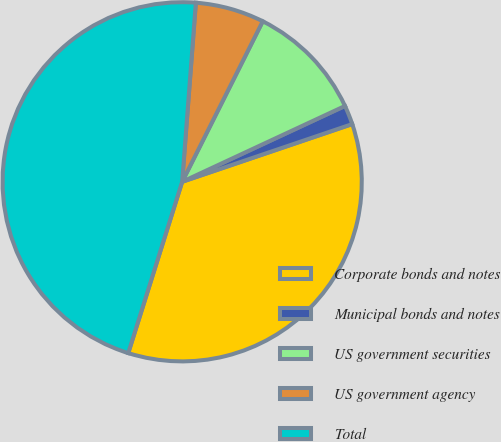<chart> <loc_0><loc_0><loc_500><loc_500><pie_chart><fcel>Corporate bonds and notes<fcel>Municipal bonds and notes<fcel>US government securities<fcel>US government agency<fcel>Total<nl><fcel>35.06%<fcel>1.73%<fcel>10.66%<fcel>6.19%<fcel>46.36%<nl></chart> 